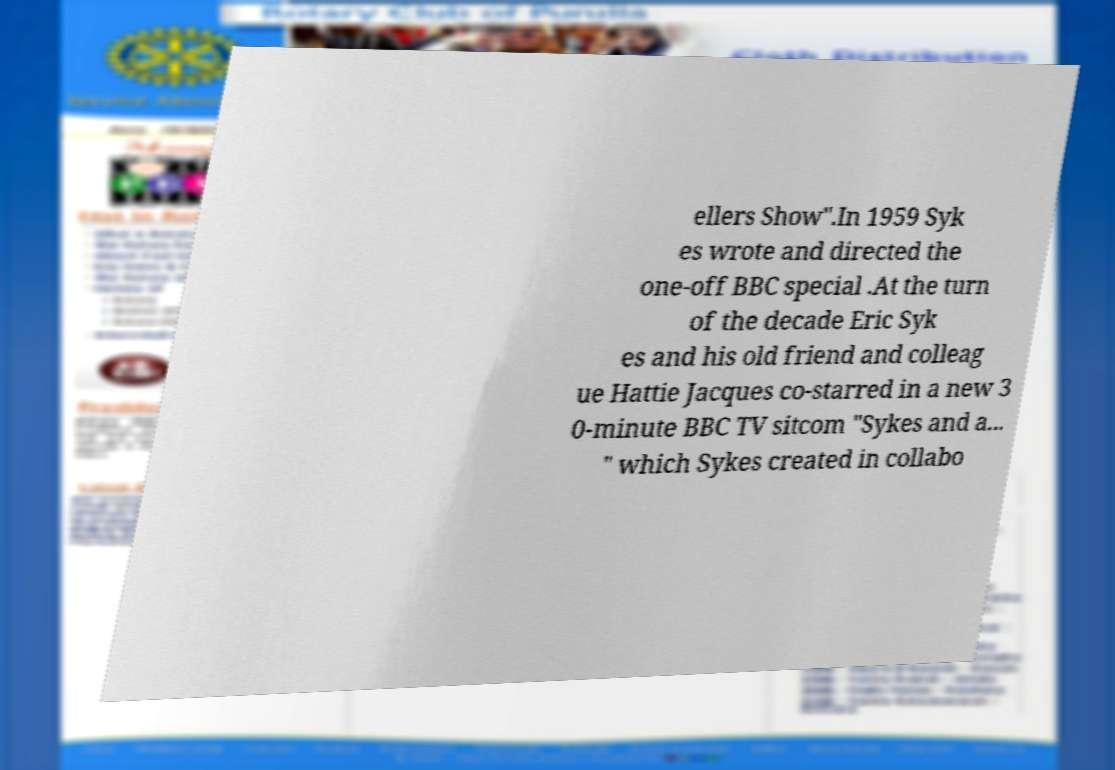For documentation purposes, I need the text within this image transcribed. Could you provide that? ellers Show".In 1959 Syk es wrote and directed the one-off BBC special .At the turn of the decade Eric Syk es and his old friend and colleag ue Hattie Jacques co-starred in a new 3 0-minute BBC TV sitcom "Sykes and a... " which Sykes created in collabo 